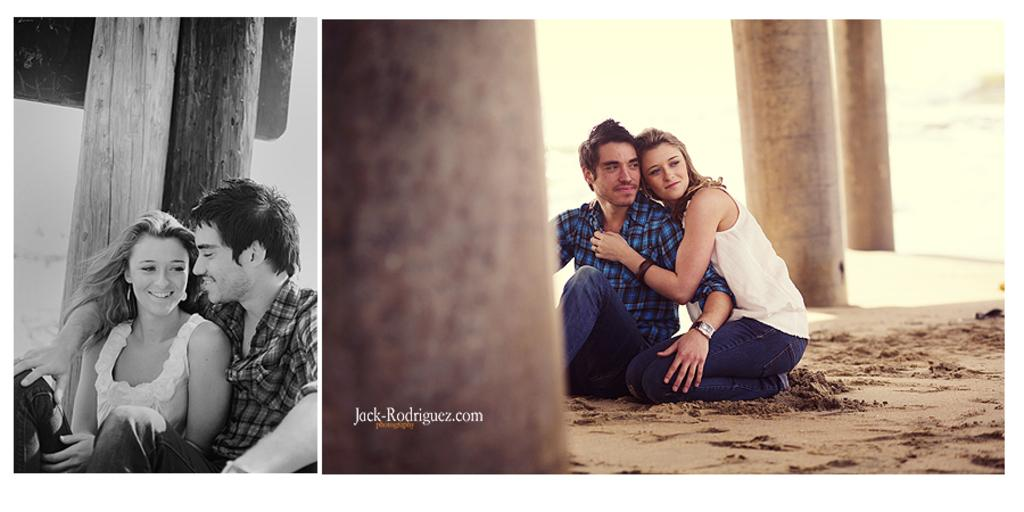What type of picture is the image? The image is a collage picture. What people can be seen in the image? There is a man and a woman in the image. What architectural features are present in the image? There are pillars in the image. Can you tell me how many toes the man has in the image? There is no information about the man's toes in the image. Is the image showing a scene from an island? There is no information about the location or setting of the image, so it cannot be determined if it is an island. 